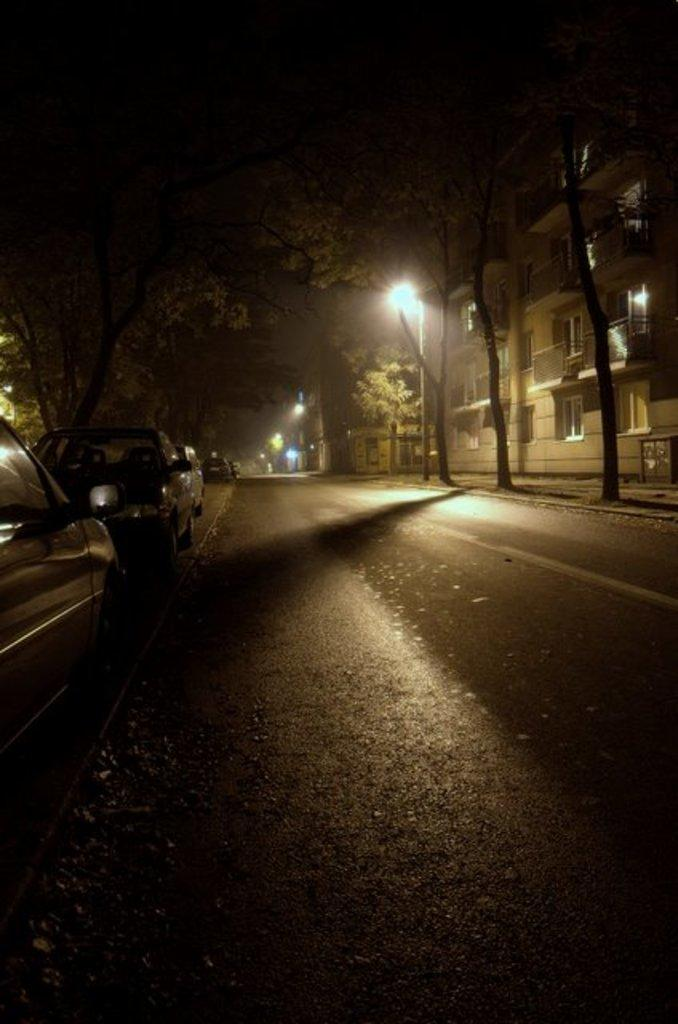What is located on the left side of the image? There are vehicles on a footpath on the left side of the image. What type of area is depicted in the image? This is a road. What can be seen in the background of the image? There are trees, lights, poles, buildings, fences, and windows in the background of the image. What type of quiver can be seen in the image? There is no quiver present in the image. How does the heat affect the vehicles in the image? The image does not provide information about the temperature or heat, so it cannot be determined how it affects the vehicles. 